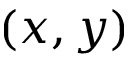Convert formula to latex. <formula><loc_0><loc_0><loc_500><loc_500>( x , y )</formula> 